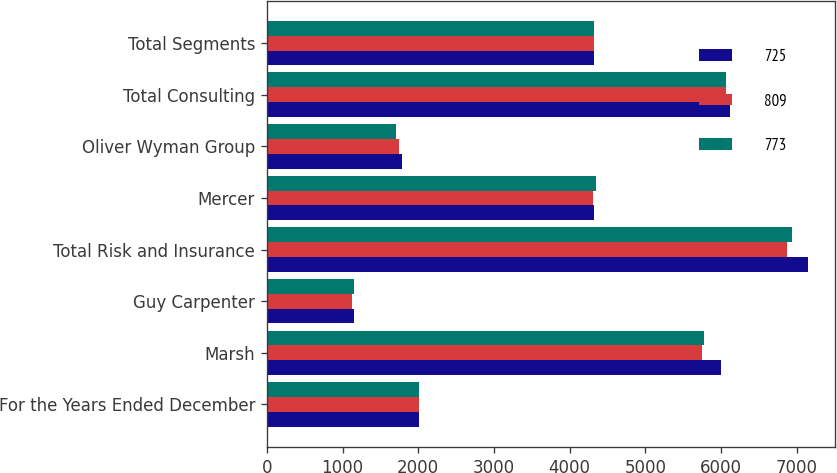Convert chart. <chart><loc_0><loc_0><loc_500><loc_500><stacked_bar_chart><ecel><fcel>For the Years Ended December<fcel>Marsh<fcel>Guy Carpenter<fcel>Total Risk and Insurance<fcel>Mercer<fcel>Oliver Wyman Group<fcel>Total Consulting<fcel>Total Segments<nl><fcel>725<fcel>2016<fcel>5997<fcel>1146<fcel>7143<fcel>4323<fcel>1789<fcel>6112<fcel>4323<nl><fcel>809<fcel>2015<fcel>5745<fcel>1124<fcel>6869<fcel>4313<fcel>1751<fcel>6064<fcel>4323<nl><fcel>773<fcel>2014<fcel>5774<fcel>1157<fcel>6931<fcel>4350<fcel>1709<fcel>6059<fcel>4323<nl></chart> 